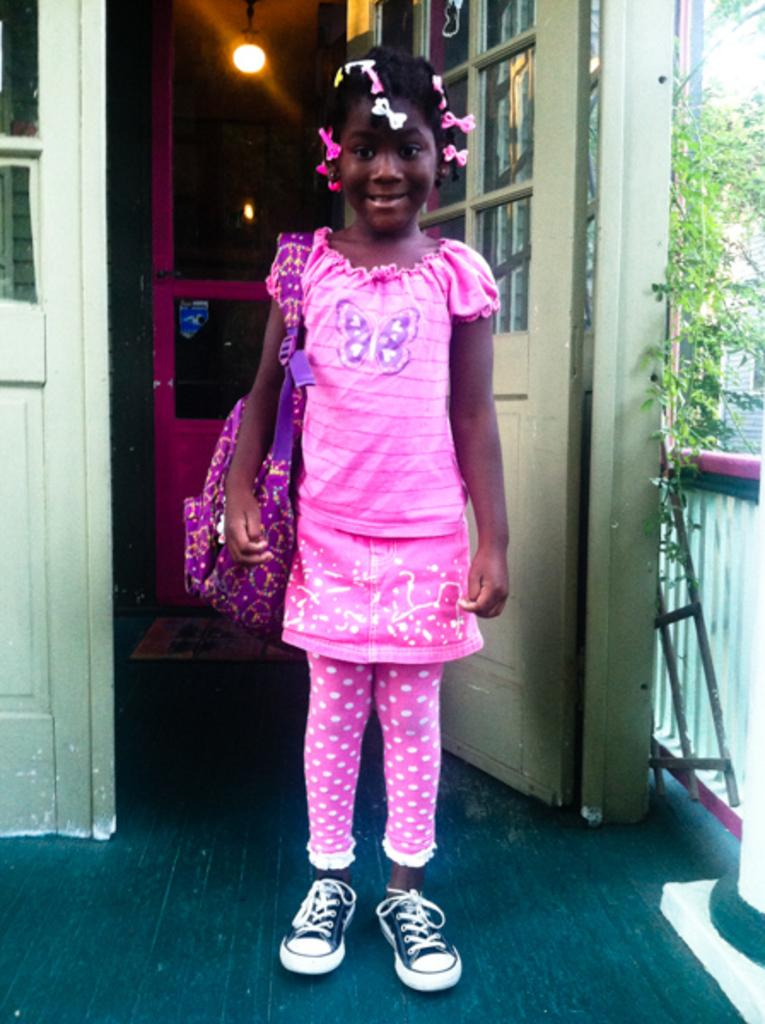Who is the main subject in the image? There is a girl in the image. What is the girl doing in the image? The girl is standing on the floor. What is the girl wearing in the image? The girl is wearing a backpack. What can be seen in the background of the image? There are creepers, pillars, doors, and an electric light in the background of the image. What type of grip does the girl have on the powder in the image? There is no powder or grip present in the image. What type of work is the girl doing in the image? The image does not show the girl doing any work; she is simply standing on the floor with a backpack. 